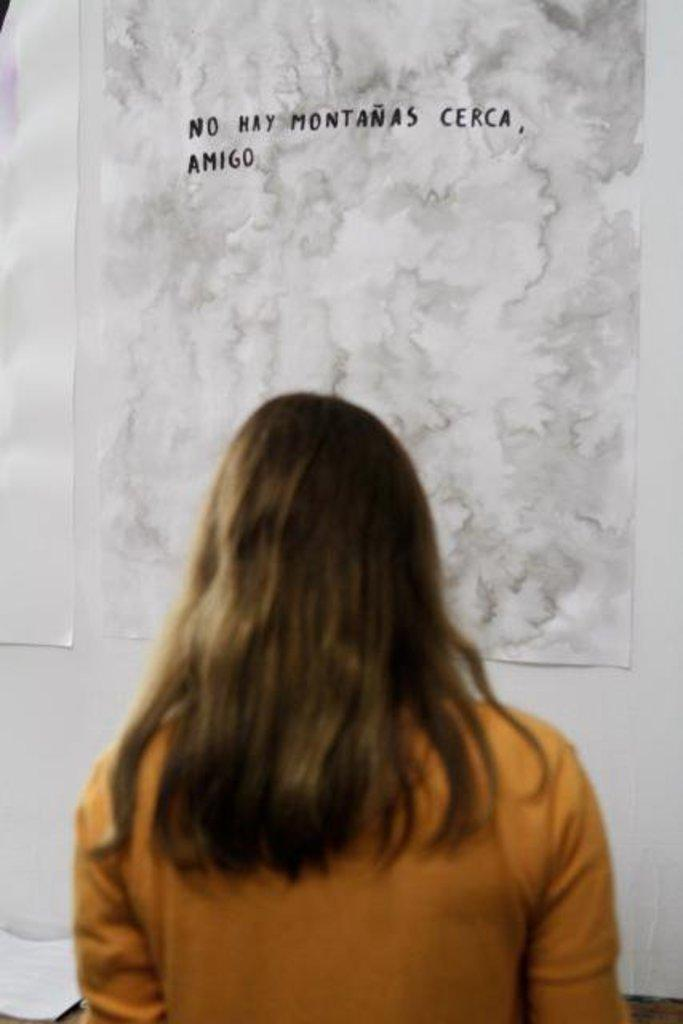What is the color and pattern of the wallpaper in the image? The wallpaper in the image is white and has a pattern. Can you describe the person in the image? There is a woman standing in the image. What type of authority does the woman have in the image? There is no indication of authority in the image, as it only shows a woman standing in front of a wallpaper. 